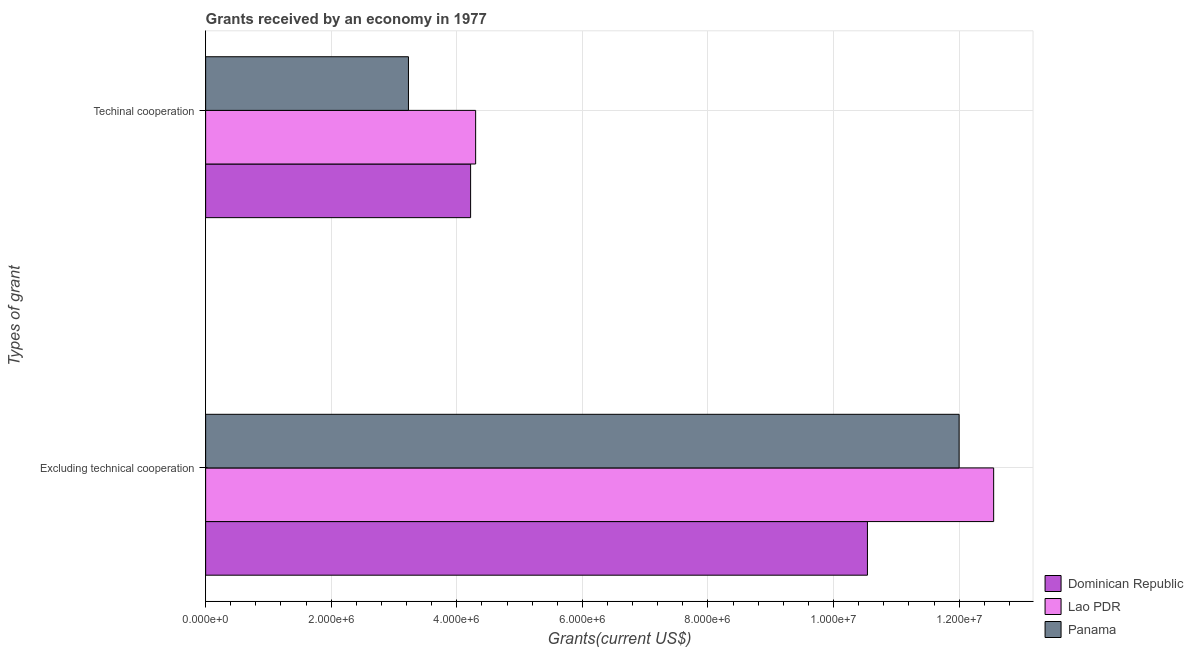How many groups of bars are there?
Offer a terse response. 2. Are the number of bars on each tick of the Y-axis equal?
Your response must be concise. Yes. How many bars are there on the 2nd tick from the top?
Ensure brevity in your answer.  3. How many bars are there on the 1st tick from the bottom?
Keep it short and to the point. 3. What is the label of the 1st group of bars from the top?
Offer a very short reply. Techinal cooperation. What is the amount of grants received(including technical cooperation) in Panama?
Your answer should be very brief. 3.23e+06. Across all countries, what is the maximum amount of grants received(excluding technical cooperation)?
Provide a succinct answer. 1.26e+07. Across all countries, what is the minimum amount of grants received(including technical cooperation)?
Your response must be concise. 3.23e+06. In which country was the amount of grants received(including technical cooperation) maximum?
Offer a terse response. Lao PDR. In which country was the amount of grants received(excluding technical cooperation) minimum?
Your answer should be compact. Dominican Republic. What is the total amount of grants received(excluding technical cooperation) in the graph?
Provide a succinct answer. 3.51e+07. What is the difference between the amount of grants received(including technical cooperation) in Dominican Republic and that in Lao PDR?
Give a very brief answer. -8.00e+04. What is the difference between the amount of grants received(excluding technical cooperation) in Dominican Republic and the amount of grants received(including technical cooperation) in Lao PDR?
Provide a short and direct response. 6.24e+06. What is the average amount of grants received(including technical cooperation) per country?
Offer a very short reply. 3.92e+06. What is the difference between the amount of grants received(excluding technical cooperation) and amount of grants received(including technical cooperation) in Panama?
Ensure brevity in your answer.  8.77e+06. What is the ratio of the amount of grants received(excluding technical cooperation) in Lao PDR to that in Panama?
Ensure brevity in your answer.  1.05. In how many countries, is the amount of grants received(excluding technical cooperation) greater than the average amount of grants received(excluding technical cooperation) taken over all countries?
Offer a terse response. 2. What does the 3rd bar from the top in Techinal cooperation represents?
Give a very brief answer. Dominican Republic. What does the 3rd bar from the bottom in Excluding technical cooperation represents?
Your answer should be very brief. Panama. How many countries are there in the graph?
Your answer should be very brief. 3. Does the graph contain any zero values?
Provide a short and direct response. No. What is the title of the graph?
Your answer should be compact. Grants received by an economy in 1977. Does "Malawi" appear as one of the legend labels in the graph?
Offer a very short reply. No. What is the label or title of the X-axis?
Make the answer very short. Grants(current US$). What is the label or title of the Y-axis?
Your response must be concise. Types of grant. What is the Grants(current US$) of Dominican Republic in Excluding technical cooperation?
Ensure brevity in your answer.  1.05e+07. What is the Grants(current US$) in Lao PDR in Excluding technical cooperation?
Give a very brief answer. 1.26e+07. What is the Grants(current US$) of Panama in Excluding technical cooperation?
Keep it short and to the point. 1.20e+07. What is the Grants(current US$) in Dominican Republic in Techinal cooperation?
Offer a very short reply. 4.22e+06. What is the Grants(current US$) in Lao PDR in Techinal cooperation?
Offer a terse response. 4.30e+06. What is the Grants(current US$) of Panama in Techinal cooperation?
Offer a terse response. 3.23e+06. Across all Types of grant, what is the maximum Grants(current US$) in Dominican Republic?
Offer a very short reply. 1.05e+07. Across all Types of grant, what is the maximum Grants(current US$) in Lao PDR?
Your answer should be very brief. 1.26e+07. Across all Types of grant, what is the minimum Grants(current US$) of Dominican Republic?
Make the answer very short. 4.22e+06. Across all Types of grant, what is the minimum Grants(current US$) in Lao PDR?
Ensure brevity in your answer.  4.30e+06. Across all Types of grant, what is the minimum Grants(current US$) of Panama?
Your answer should be very brief. 3.23e+06. What is the total Grants(current US$) of Dominican Republic in the graph?
Offer a very short reply. 1.48e+07. What is the total Grants(current US$) in Lao PDR in the graph?
Keep it short and to the point. 1.68e+07. What is the total Grants(current US$) in Panama in the graph?
Make the answer very short. 1.52e+07. What is the difference between the Grants(current US$) of Dominican Republic in Excluding technical cooperation and that in Techinal cooperation?
Give a very brief answer. 6.32e+06. What is the difference between the Grants(current US$) in Lao PDR in Excluding technical cooperation and that in Techinal cooperation?
Keep it short and to the point. 8.25e+06. What is the difference between the Grants(current US$) in Panama in Excluding technical cooperation and that in Techinal cooperation?
Ensure brevity in your answer.  8.77e+06. What is the difference between the Grants(current US$) of Dominican Republic in Excluding technical cooperation and the Grants(current US$) of Lao PDR in Techinal cooperation?
Ensure brevity in your answer.  6.24e+06. What is the difference between the Grants(current US$) in Dominican Republic in Excluding technical cooperation and the Grants(current US$) in Panama in Techinal cooperation?
Your response must be concise. 7.31e+06. What is the difference between the Grants(current US$) in Lao PDR in Excluding technical cooperation and the Grants(current US$) in Panama in Techinal cooperation?
Ensure brevity in your answer.  9.32e+06. What is the average Grants(current US$) in Dominican Republic per Types of grant?
Offer a very short reply. 7.38e+06. What is the average Grants(current US$) in Lao PDR per Types of grant?
Ensure brevity in your answer.  8.42e+06. What is the average Grants(current US$) of Panama per Types of grant?
Provide a short and direct response. 7.62e+06. What is the difference between the Grants(current US$) in Dominican Republic and Grants(current US$) in Lao PDR in Excluding technical cooperation?
Offer a very short reply. -2.01e+06. What is the difference between the Grants(current US$) of Dominican Republic and Grants(current US$) of Panama in Excluding technical cooperation?
Your answer should be compact. -1.46e+06. What is the difference between the Grants(current US$) of Lao PDR and Grants(current US$) of Panama in Excluding technical cooperation?
Offer a very short reply. 5.50e+05. What is the difference between the Grants(current US$) of Dominican Republic and Grants(current US$) of Panama in Techinal cooperation?
Offer a very short reply. 9.90e+05. What is the difference between the Grants(current US$) in Lao PDR and Grants(current US$) in Panama in Techinal cooperation?
Offer a very short reply. 1.07e+06. What is the ratio of the Grants(current US$) of Dominican Republic in Excluding technical cooperation to that in Techinal cooperation?
Offer a very short reply. 2.5. What is the ratio of the Grants(current US$) in Lao PDR in Excluding technical cooperation to that in Techinal cooperation?
Your answer should be very brief. 2.92. What is the ratio of the Grants(current US$) in Panama in Excluding technical cooperation to that in Techinal cooperation?
Give a very brief answer. 3.72. What is the difference between the highest and the second highest Grants(current US$) of Dominican Republic?
Give a very brief answer. 6.32e+06. What is the difference between the highest and the second highest Grants(current US$) of Lao PDR?
Provide a succinct answer. 8.25e+06. What is the difference between the highest and the second highest Grants(current US$) of Panama?
Your response must be concise. 8.77e+06. What is the difference between the highest and the lowest Grants(current US$) of Dominican Republic?
Give a very brief answer. 6.32e+06. What is the difference between the highest and the lowest Grants(current US$) in Lao PDR?
Provide a short and direct response. 8.25e+06. What is the difference between the highest and the lowest Grants(current US$) in Panama?
Your answer should be very brief. 8.77e+06. 